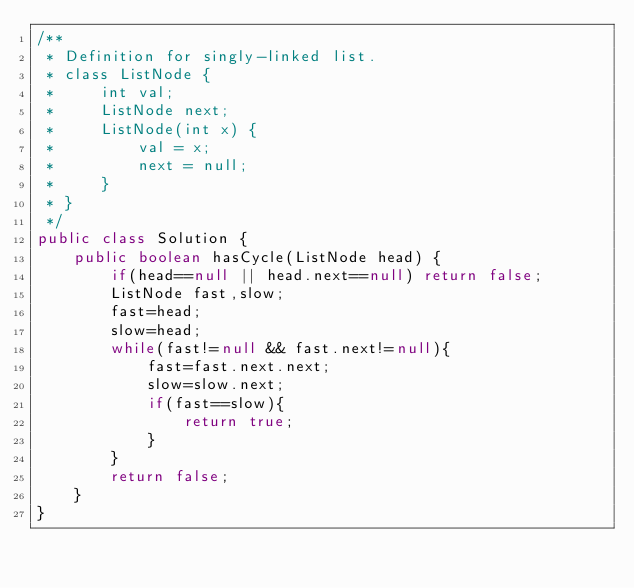Convert code to text. <code><loc_0><loc_0><loc_500><loc_500><_Java_>/**
 * Definition for singly-linked list.
 * class ListNode {
 *     int val;
 *     ListNode next;
 *     ListNode(int x) {
 *         val = x;
 *         next = null;
 *     }
 * }
 */
public class Solution {
    public boolean hasCycle(ListNode head) {
        if(head==null || head.next==null) return false;
        ListNode fast,slow;
        fast=head;
        slow=head;
        while(fast!=null && fast.next!=null){
            fast=fast.next.next;
            slow=slow.next;
            if(fast==slow){
                return true;
            }
        }
        return false;
    }
}</code> 